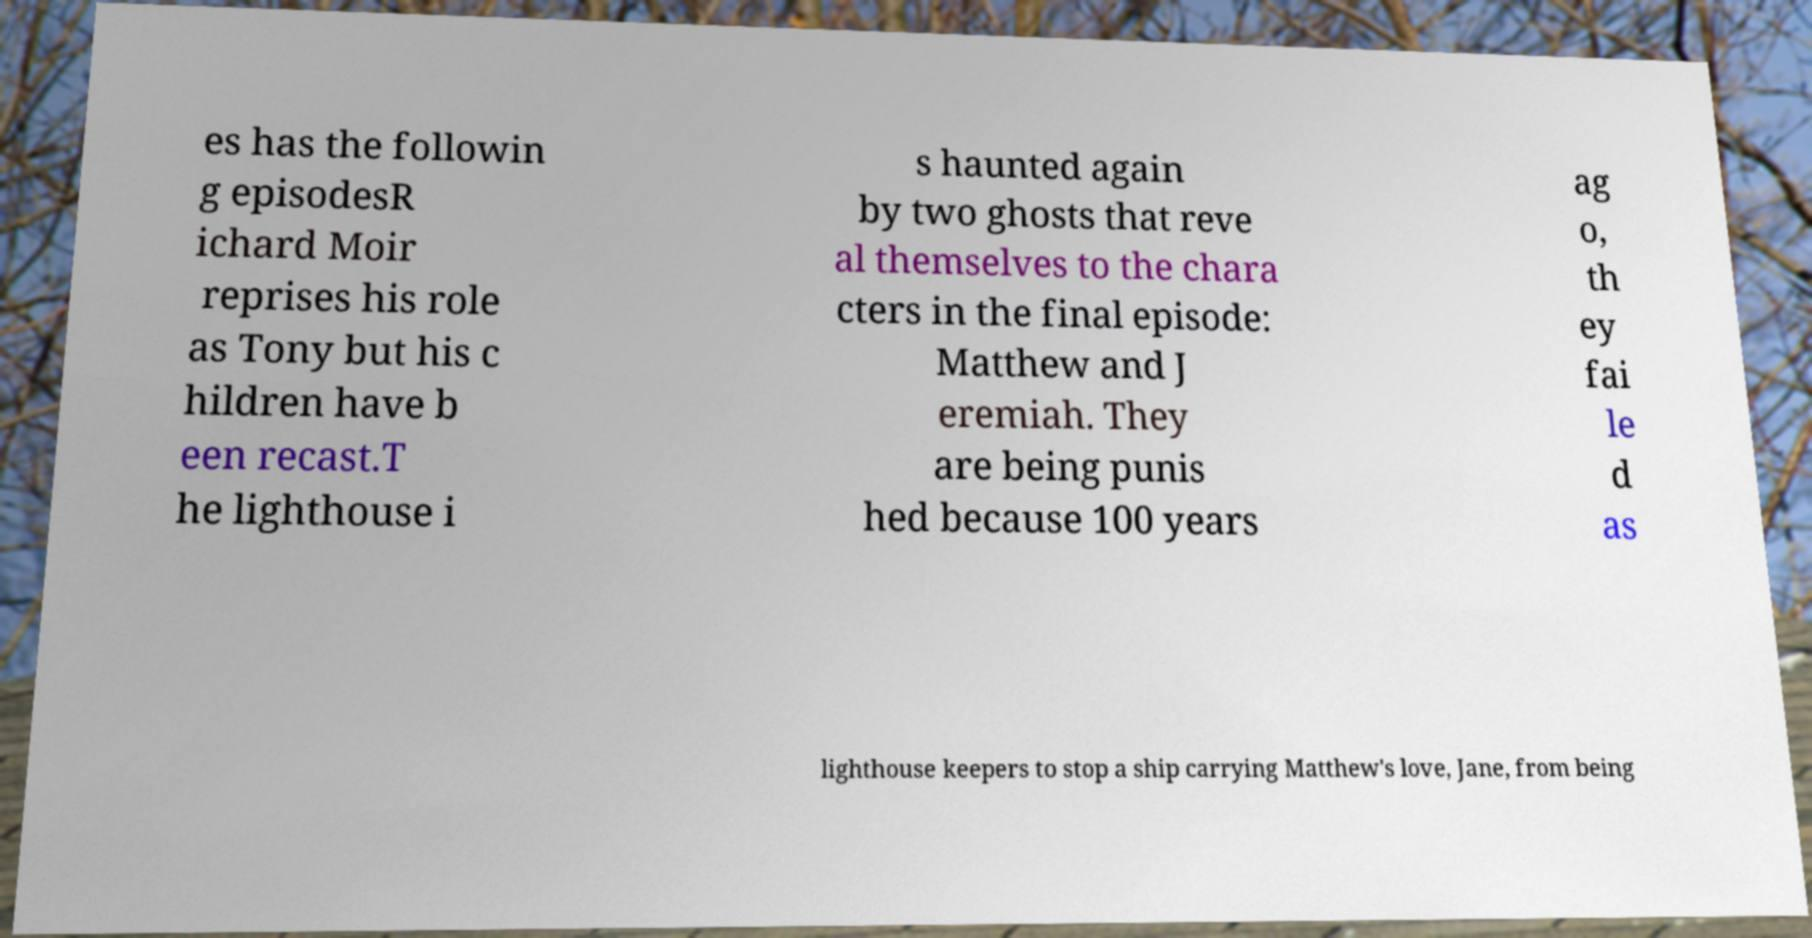Could you extract and type out the text from this image? es has the followin g episodesR ichard Moir reprises his role as Tony but his c hildren have b een recast.T he lighthouse i s haunted again by two ghosts that reve al themselves to the chara cters in the final episode: Matthew and J eremiah. They are being punis hed because 100 years ag o, th ey fai le d as lighthouse keepers to stop a ship carrying Matthew's love, Jane, from being 